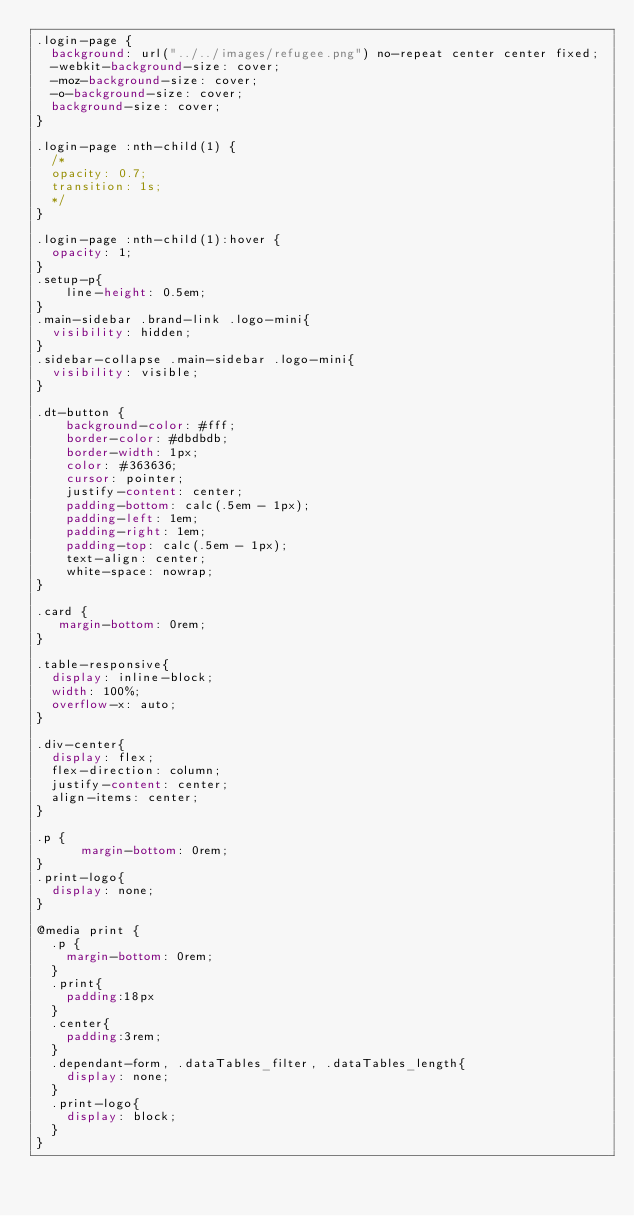<code> <loc_0><loc_0><loc_500><loc_500><_CSS_>.login-page {
  background: url("../../images/refugee.png") no-repeat center center fixed;
  -webkit-background-size: cover;
  -moz-background-size: cover;
  -o-background-size: cover;
  background-size: cover;
}

.login-page :nth-child(1) {
  /*
  opacity: 0.7;
  transition: 1s;
  */
}

.login-page :nth-child(1):hover {
  opacity: 1;
}
.setup-p{
    line-height: 0.5em;
}
.main-sidebar .brand-link .logo-mini{
	visibility: hidden;
}
.sidebar-collapse .main-sidebar .logo-mini{
	visibility: visible;
}

.dt-button {
    background-color: #fff;
    border-color: #dbdbdb;
    border-width: 1px;
    color: #363636;
    cursor: pointer;
    justify-content: center;
    padding-bottom: calc(.5em - 1px);
    padding-left: 1em;
    padding-right: 1em;
    padding-top: calc(.5em - 1px);
    text-align: center;
    white-space: nowrap;
}

.card {
   margin-bottom: 0rem;
}

.table-responsive{
  display: inline-block;
  width: 100%;
  overflow-x: auto;
}

.div-center{
  display: flex;
  flex-direction: column;
  justify-content: center;
  align-items: center;
}

.p {
      margin-bottom: 0rem;
}
.print-logo{
  display: none;
}

@media print {
  .p {
    margin-bottom: 0rem;
  }
  .print{
    padding:18px
  }
  .center{
    padding:3rem;
  }
  .dependant-form, .dataTables_filter, .dataTables_length{
    display: none;
  }
  .print-logo{
    display: block;
  }
}
</code> 